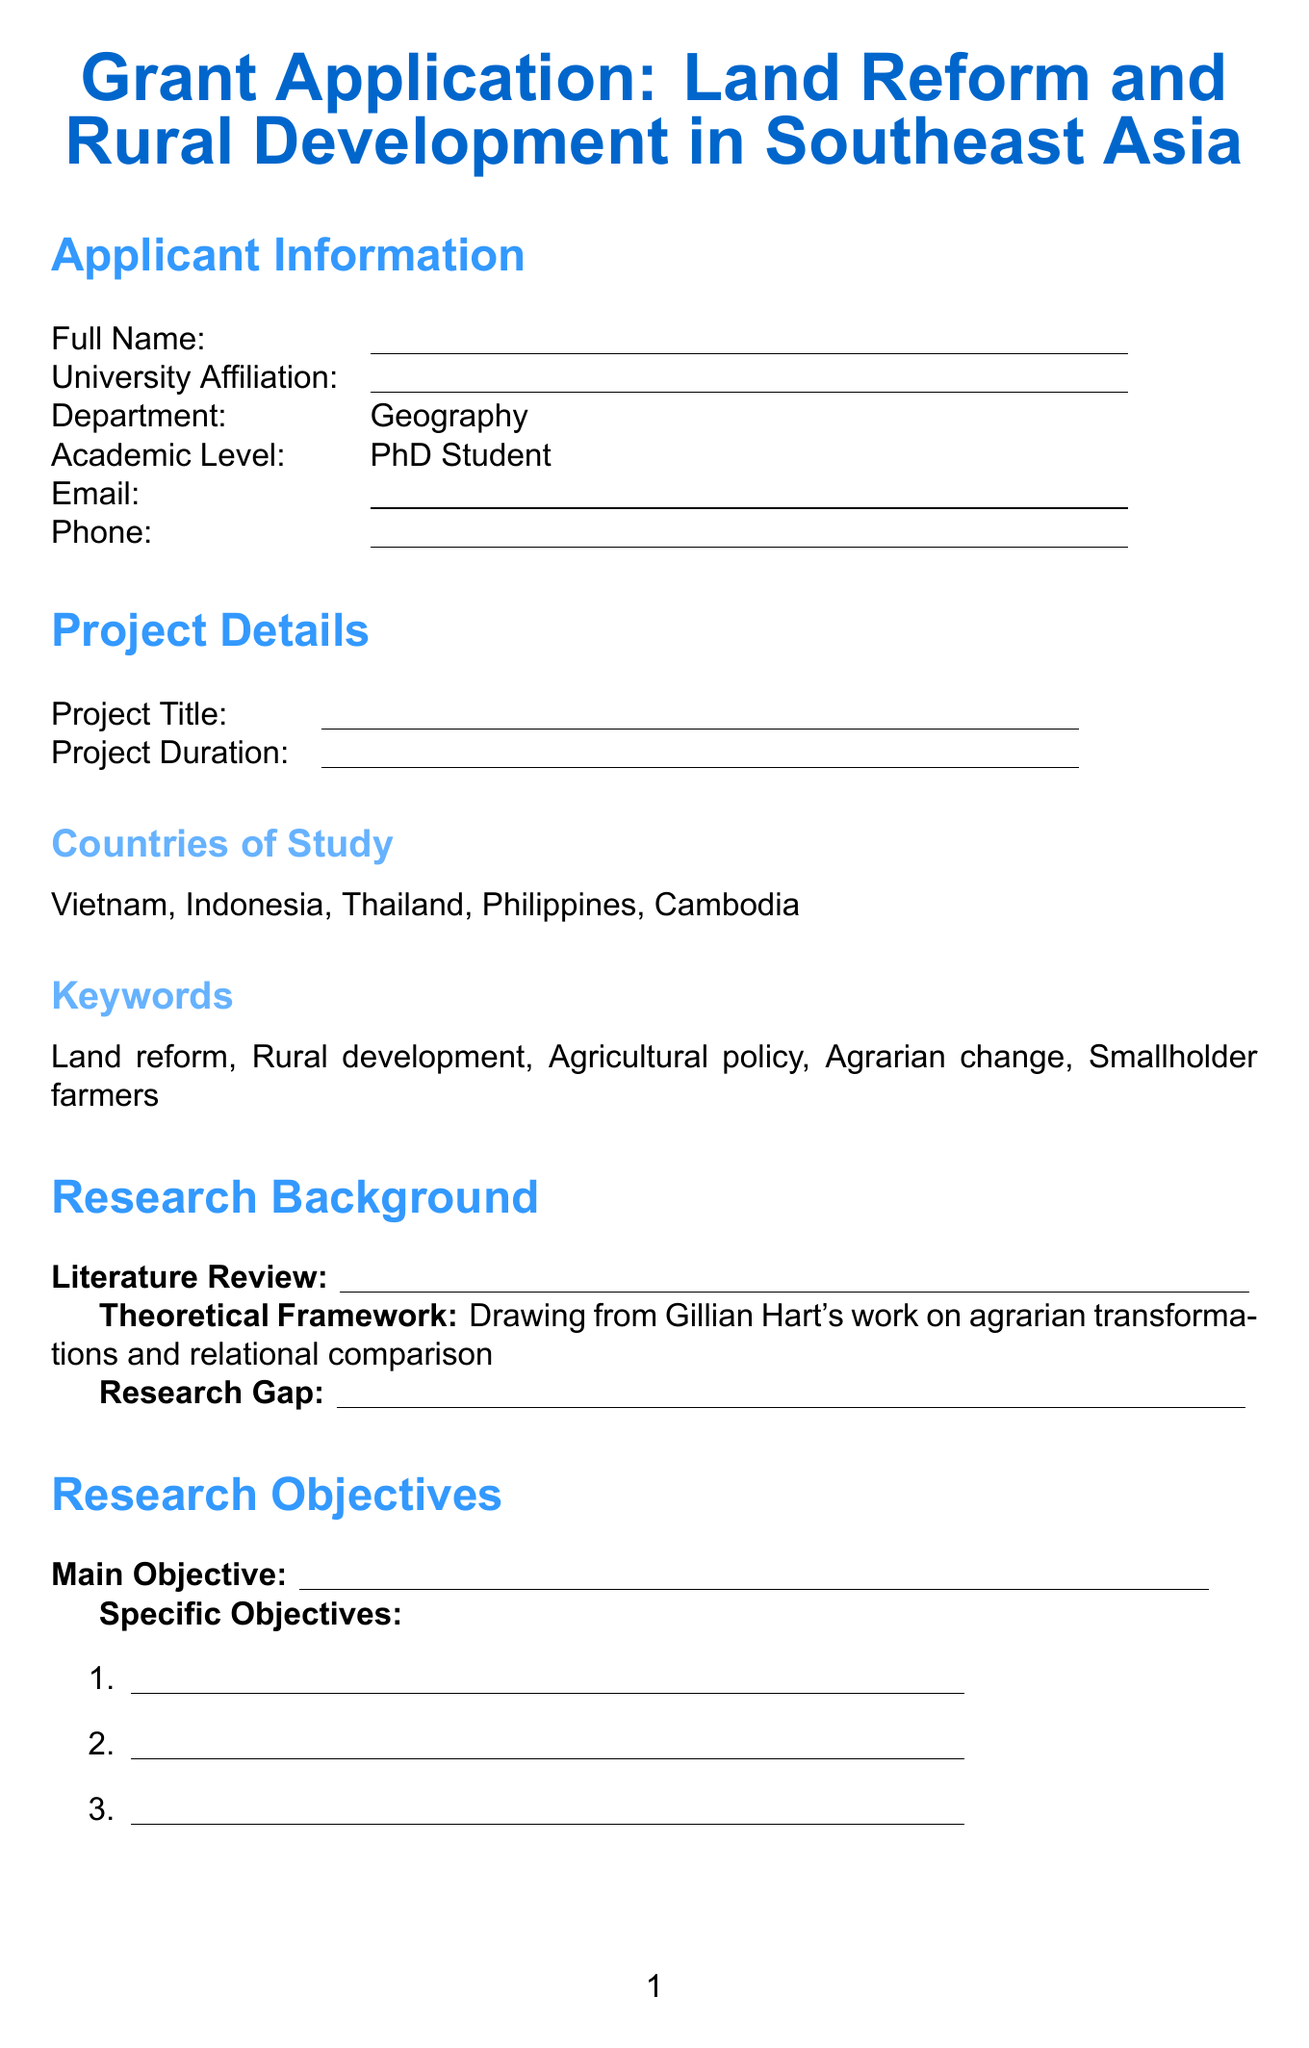What are the countries of study? This information lists the specific Southeast Asian countries involved in the research project.
Answer: Vietnam, Indonesia, Thailand, Philippines, Cambodia How many months is the fieldwork planned to last? This detail is derived from the timeline section specifying the duration of fieldwork activities in the countries studied.
Answer: 12 months Which university is collaborating with the project in Thailand? This identifies one of the partnering institutions and the country they are located in, relevant for collaboration aspects.
Answer: Chulalongkorn University What data collection methods are mentioned? This refers to the methods used to gather data for the research, important for the methodology section.
Answer: Semi-structured interviews, Participant observation, Archival research, GIS mapping What is the duration for literature review and research design? This entails a specific milestone in the timeline, highlighting the initial phase of the research process.
Answer: 3 months What is the theoretical framework based on? This is centered on the philosophical foundation guiding the research approach mentioned in the document.
Answer: Gillian Hart's work on agrarian transformations and relational comparison 